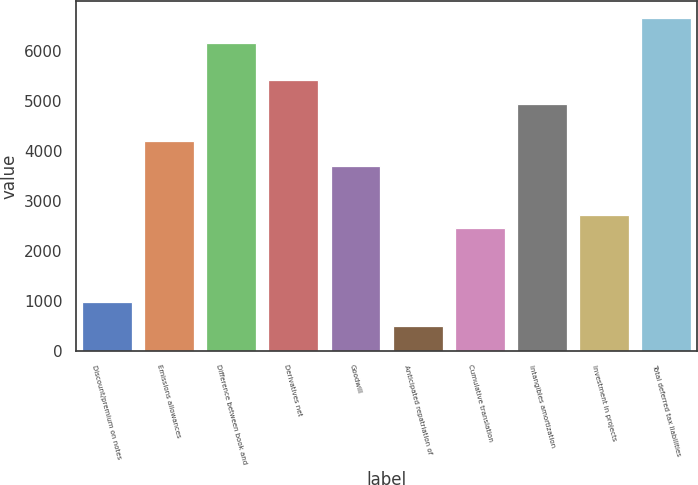<chart> <loc_0><loc_0><loc_500><loc_500><bar_chart><fcel>Discount/premium on notes<fcel>Emissions allowances<fcel>Difference between book and<fcel>Derivatives net<fcel>Goodwill<fcel>Anticipated repatriation of<fcel>Cumulative translation<fcel>Intangibles amortization<fcel>Investment in projects<fcel>Total deferred tax liabilities<nl><fcel>986.6<fcel>4189.8<fcel>6161<fcel>5421.8<fcel>3697<fcel>493.8<fcel>2465<fcel>4929<fcel>2711.4<fcel>6653.8<nl></chart> 